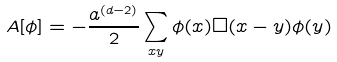Convert formula to latex. <formula><loc_0><loc_0><loc_500><loc_500>A [ \phi ] = - \frac { a ^ { ( d - 2 ) } } { 2 } \sum _ { x y } \phi ( x ) \Box ( x - y ) \phi ( y )</formula> 